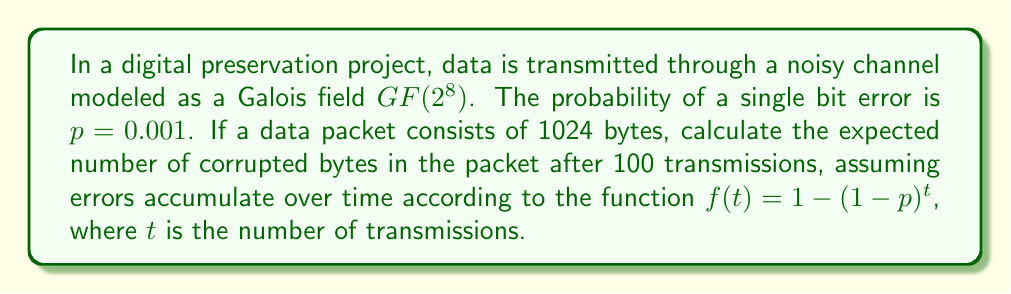Solve this math problem. 1. First, we need to understand the Galois field $GF(2^8)$:
   - Each element in this field represents a byte (8 bits).
   - The field has $2^8 = 256$ elements.

2. Probability of a byte being correct after one transmission:
   $P(\text{correct byte}) = (1-p)^8 = (0.999)^8 = 0.992032$

3. Probability of a byte being corrupted after one transmission:
   $P(\text{corrupted byte}) = 1 - P(\text{correct byte}) = 1 - 0.992032 = 0.007968$

4. Using the given function $f(t) = 1 - (1-p)^t$, we can calculate the probability of a bit being corrupted after 100 transmissions:
   $f(100) = 1 - (1-0.001)^{100} = 1 - 0.904837 = 0.095163$

5. Probability of a byte being corrupted after 100 transmissions:
   $P(\text{corrupted byte after 100}) = 1 - (1-0.095163)^8 = 0.554999$

6. Expected number of corrupted bytes in a 1024-byte packet after 100 transmissions:
   $E(\text{corrupted bytes}) = 1024 * 0.554999 = 568.3190$

Therefore, the expected number of corrupted bytes in the packet after 100 transmissions is approximately 568.32 bytes.
Answer: 568.32 bytes 